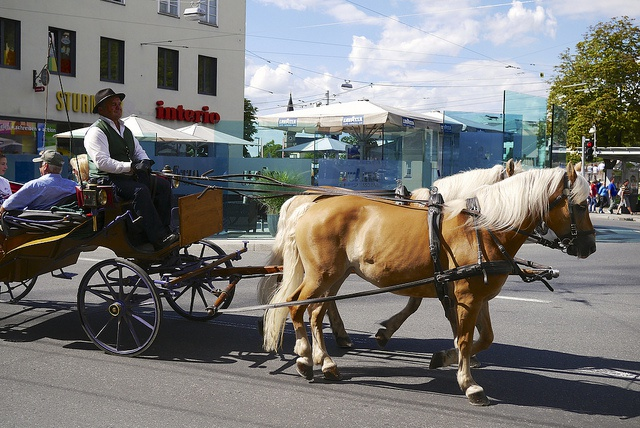Describe the objects in this image and their specific colors. I can see horse in gray, black, ivory, maroon, and tan tones, people in gray, black, lightgray, and darkgray tones, horse in gray, ivory, black, and darkgray tones, people in gray, black, purple, blue, and navy tones, and umbrella in gray, lightgray, and darkgray tones in this image. 